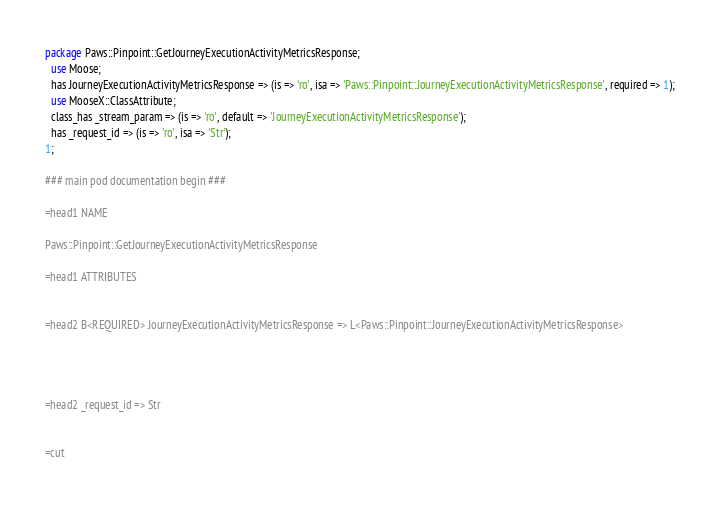Convert code to text. <code><loc_0><loc_0><loc_500><loc_500><_Perl_>
package Paws::Pinpoint::GetJourneyExecutionActivityMetricsResponse;
  use Moose;
  has JourneyExecutionActivityMetricsResponse => (is => 'ro', isa => 'Paws::Pinpoint::JourneyExecutionActivityMetricsResponse', required => 1);
  use MooseX::ClassAttribute;
  class_has _stream_param => (is => 'ro', default => 'JourneyExecutionActivityMetricsResponse');
  has _request_id => (is => 'ro', isa => 'Str');
1;

### main pod documentation begin ###

=head1 NAME

Paws::Pinpoint::GetJourneyExecutionActivityMetricsResponse

=head1 ATTRIBUTES


=head2 B<REQUIRED> JourneyExecutionActivityMetricsResponse => L<Paws::Pinpoint::JourneyExecutionActivityMetricsResponse>




=head2 _request_id => Str


=cut

</code> 